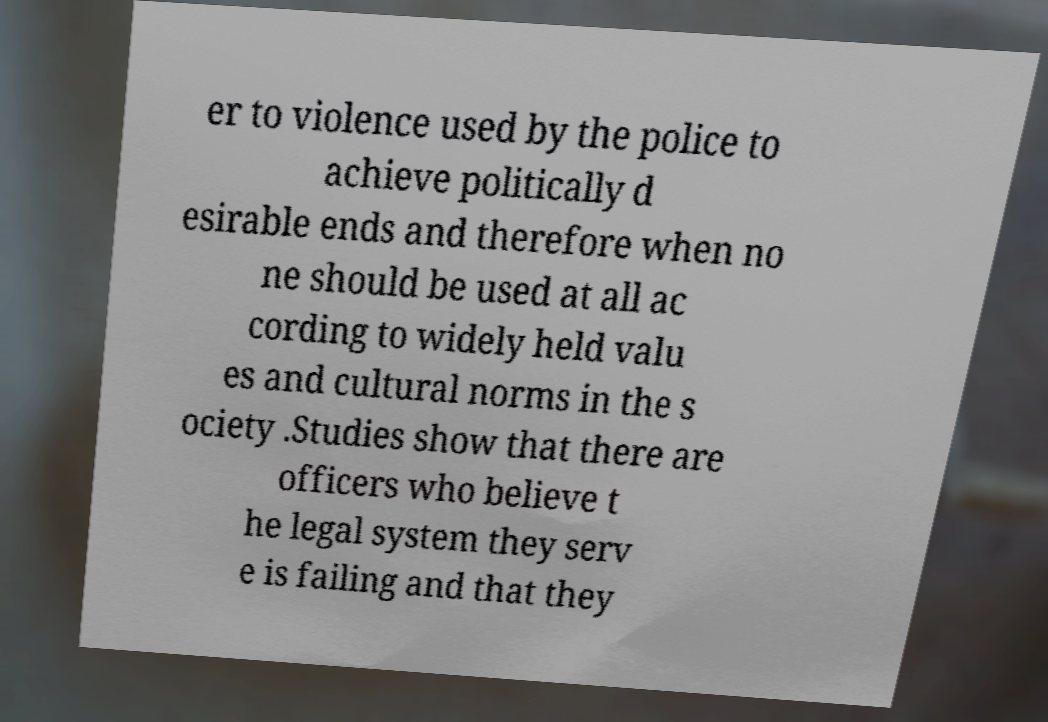Could you assist in decoding the text presented in this image and type it out clearly? er to violence used by the police to achieve politically d esirable ends and therefore when no ne should be used at all ac cording to widely held valu es and cultural norms in the s ociety .Studies show that there are officers who believe t he legal system they serv e is failing and that they 